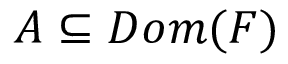Convert formula to latex. <formula><loc_0><loc_0><loc_500><loc_500>A \subseteq D o m ( F )</formula> 